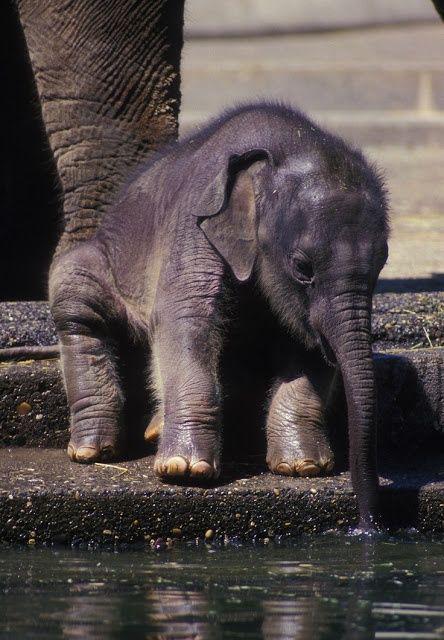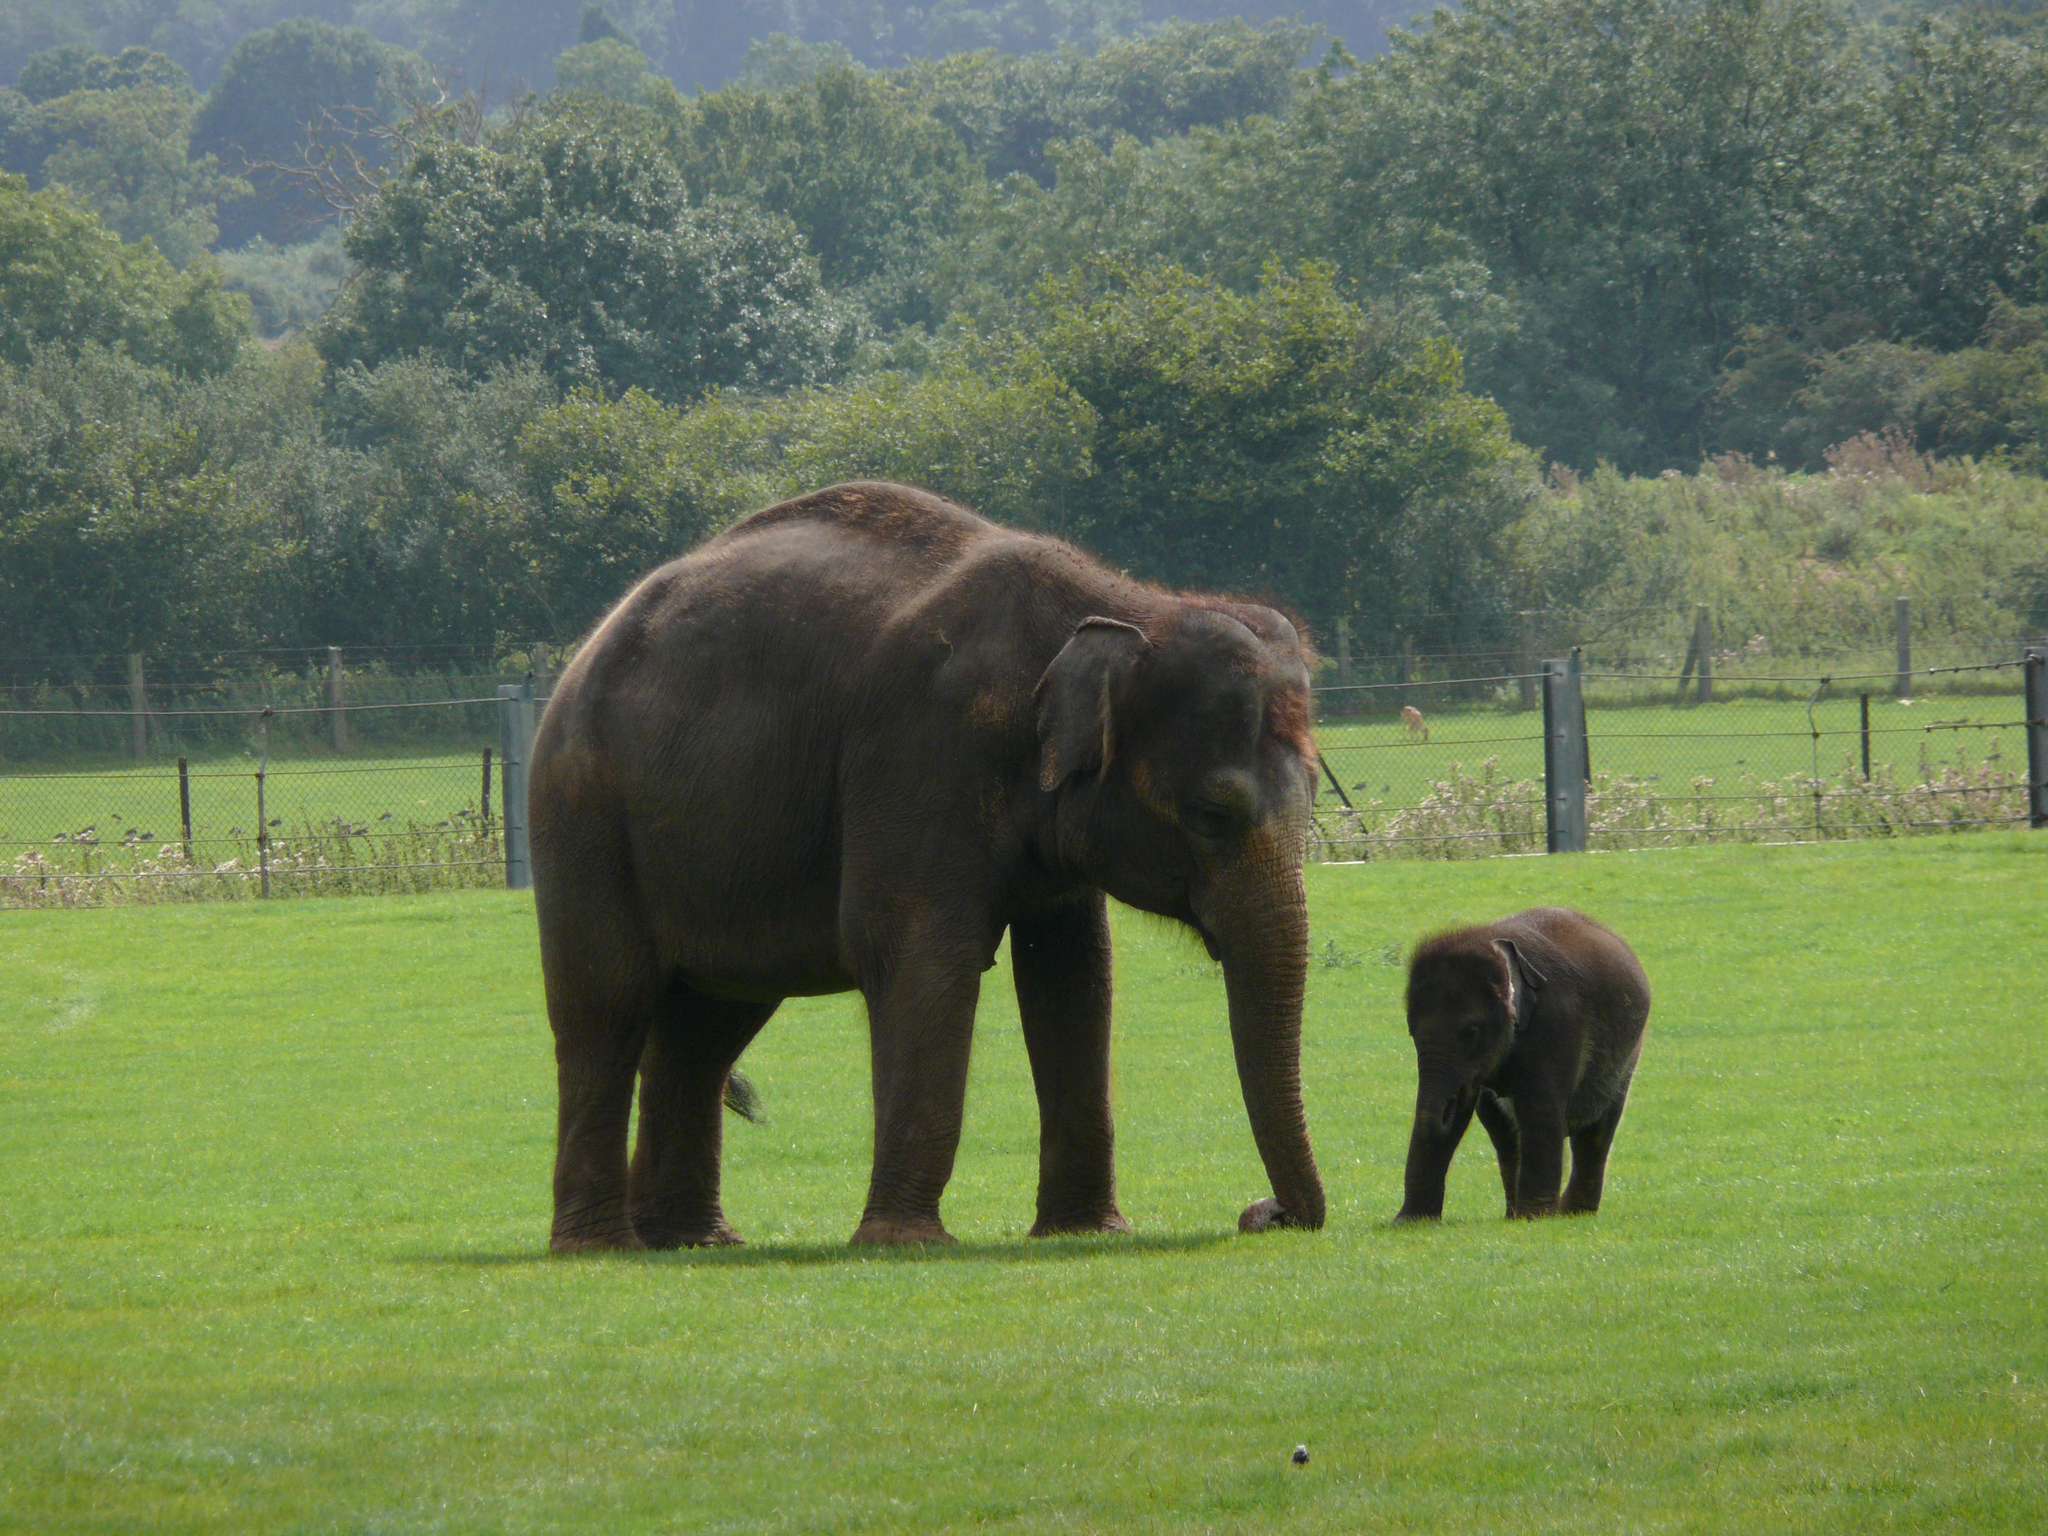The first image is the image on the left, the second image is the image on the right. Assess this claim about the two images: "There are no more than 4 elephants in total.". Correct or not? Answer yes or no. Yes. The first image is the image on the left, the second image is the image on the right. Evaluate the accuracy of this statement regarding the images: "An image shows a person interacting with one elephant.". Is it true? Answer yes or no. No. 